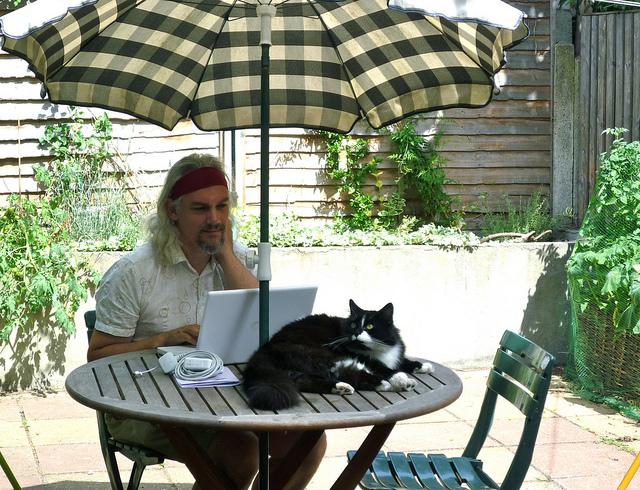Is the man sitting in the garden?
Keep it brief. Yes. What is creating the shade?
Keep it brief. Umbrella. What color is the cat?
Quick response, please. Black and white. 